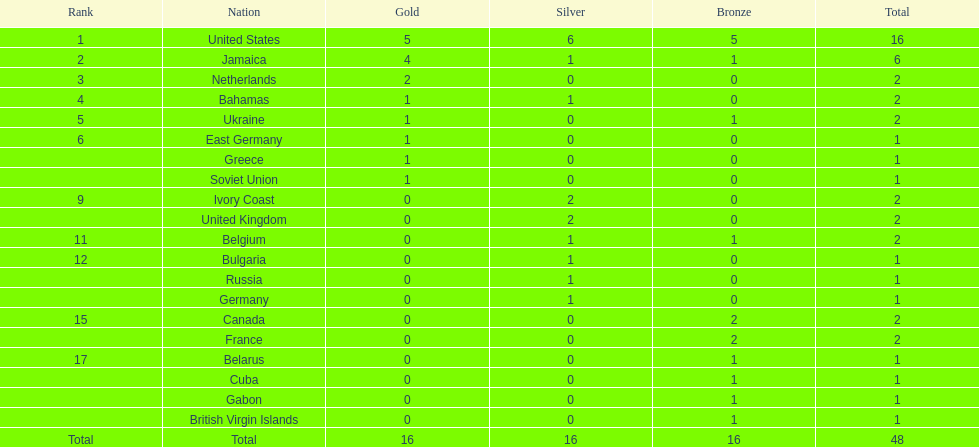How many countries secured 1 medal? 10. 